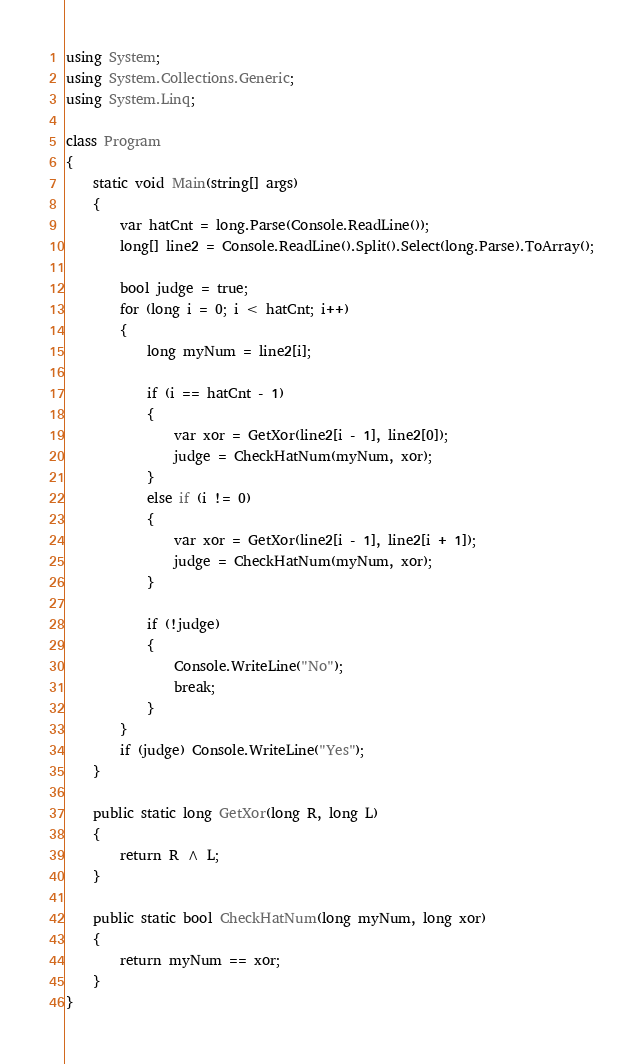Convert code to text. <code><loc_0><loc_0><loc_500><loc_500><_C#_>using System;
using System.Collections.Generic;
using System.Linq;

class Program
{
    static void Main(string[] args)
    {
        var hatCnt = long.Parse(Console.ReadLine());
        long[] line2 = Console.ReadLine().Split().Select(long.Parse).ToArray();

        bool judge = true;
        for (long i = 0; i < hatCnt; i++)
        {
            long myNum = line2[i];

            if (i == hatCnt - 1)
            {
                var xor = GetXor(line2[i - 1], line2[0]);
                judge = CheckHatNum(myNum, xor);
            }
            else if (i != 0)
            {
                var xor = GetXor(line2[i - 1], line2[i + 1]);
                judge = CheckHatNum(myNum, xor);
            }

            if (!judge)
            {
                Console.WriteLine("No");
                break;
            }
        }
        if (judge) Console.WriteLine("Yes");
    }

    public static long GetXor(long R, long L)
    {
        return R ^ L;
    }

    public static bool CheckHatNum(long myNum, long xor)
    {
        return myNum == xor;
    }
}
</code> 